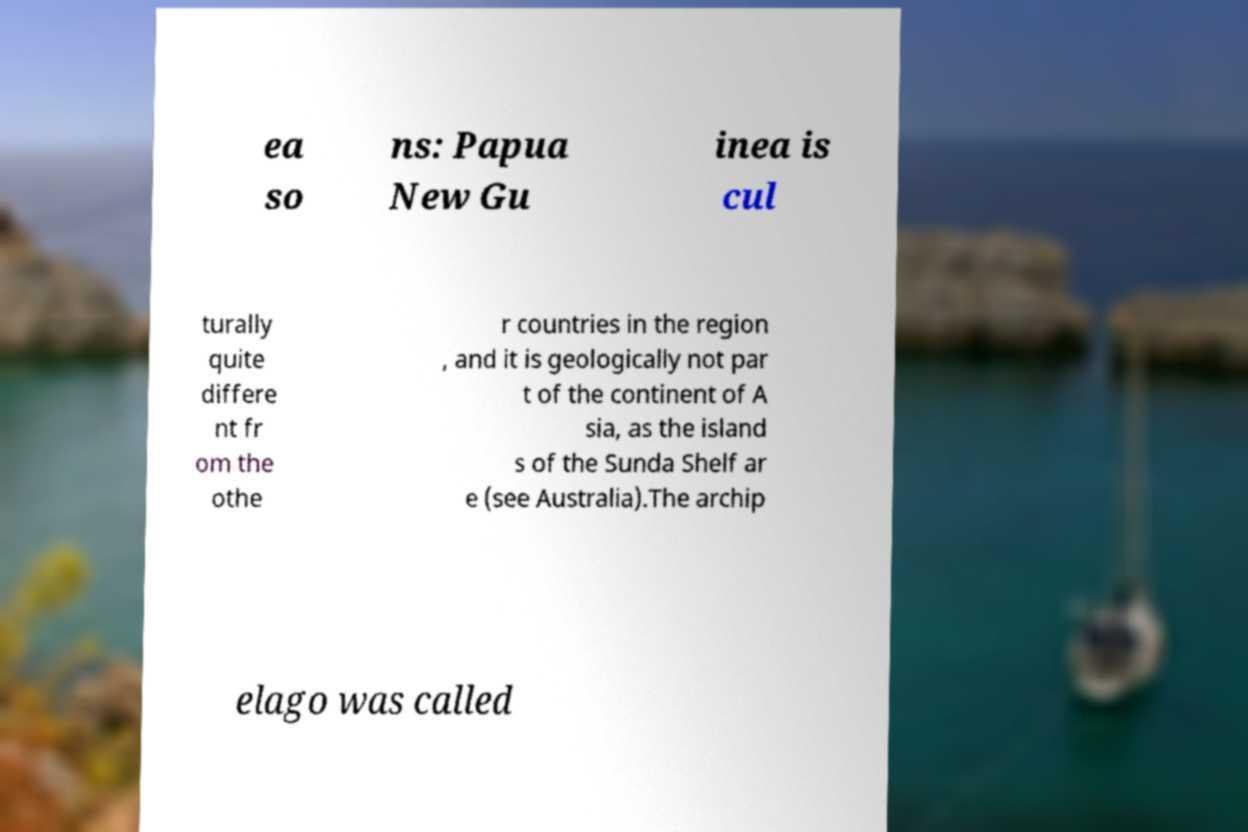There's text embedded in this image that I need extracted. Can you transcribe it verbatim? ea so ns: Papua New Gu inea is cul turally quite differe nt fr om the othe r countries in the region , and it is geologically not par t of the continent of A sia, as the island s of the Sunda Shelf ar e (see Australia).The archip elago was called 